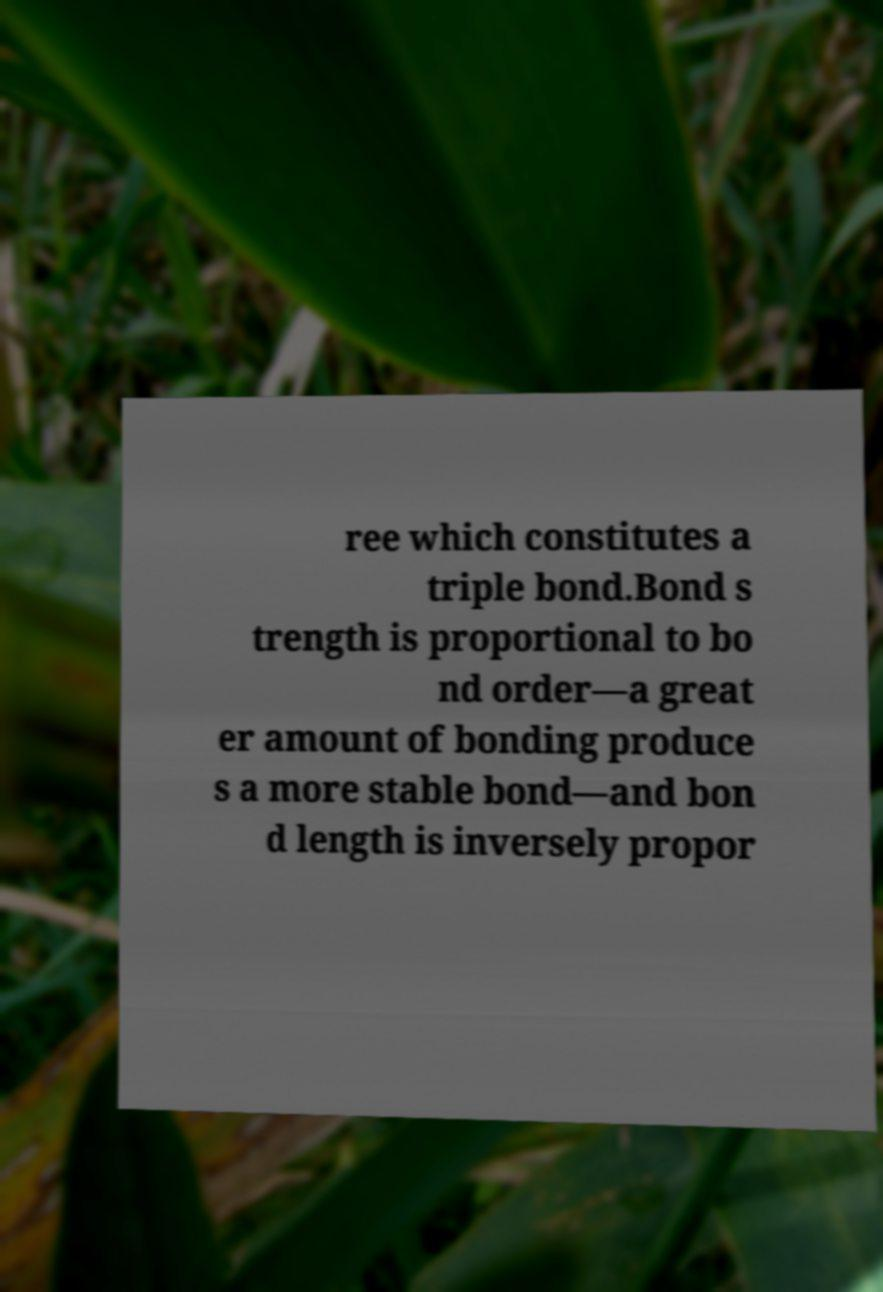For documentation purposes, I need the text within this image transcribed. Could you provide that? ree which constitutes a triple bond.Bond s trength is proportional to bo nd order—a great er amount of bonding produce s a more stable bond—and bon d length is inversely propor 